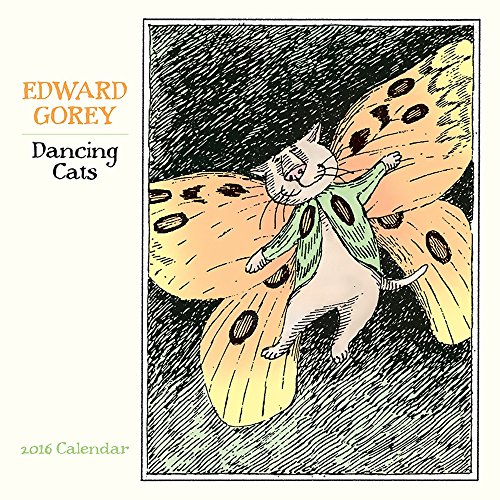Could you describe the art style used in the illustration on this calendar? Certainly! The art style of the illustration is distinctly Gorey-esque, characterized by a blend of Victorian and Edwardian influences, with a touch of surrealism, particularly evident in the anthropomorphic depiction of the dancing cat. 